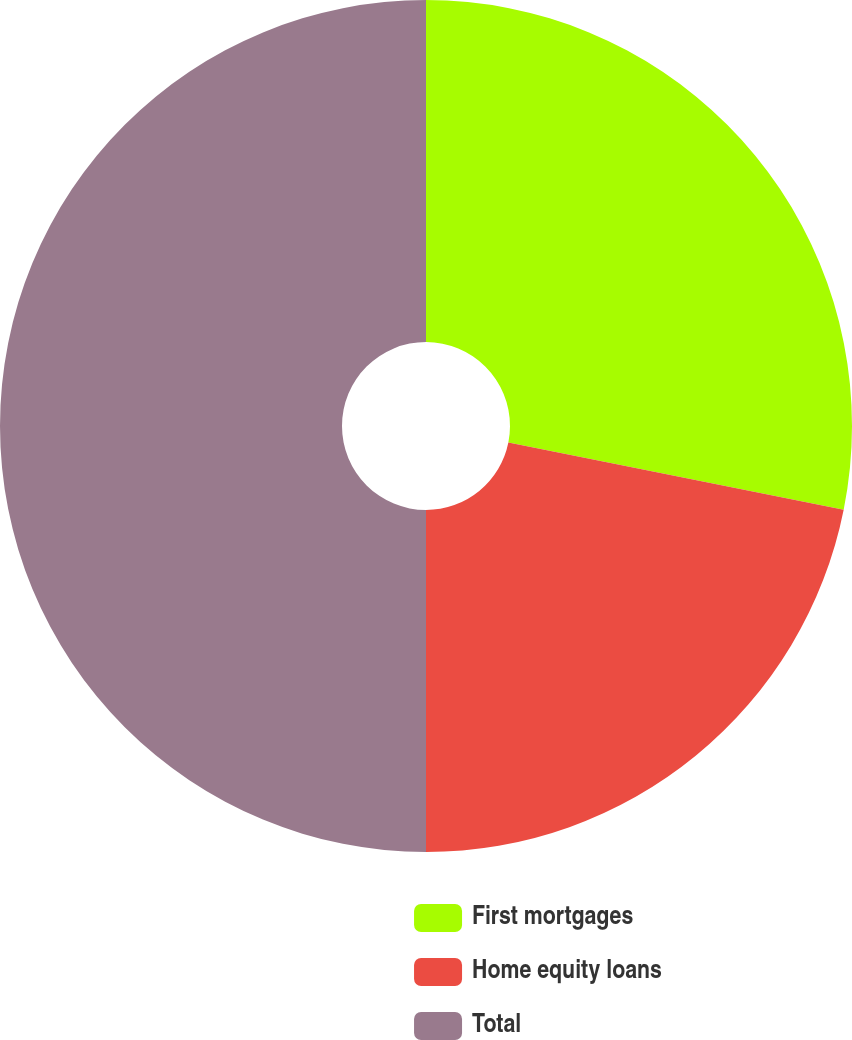Convert chart. <chart><loc_0><loc_0><loc_500><loc_500><pie_chart><fcel>First mortgages<fcel>Home equity loans<fcel>Total<nl><fcel>28.15%<fcel>21.85%<fcel>50.0%<nl></chart> 